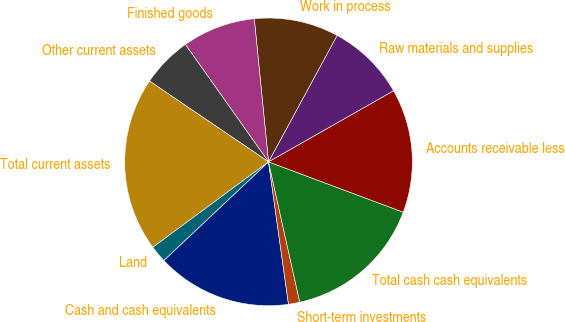<chart> <loc_0><loc_0><loc_500><loc_500><pie_chart><fcel>Cash and cash equivalents<fcel>Short-term investments<fcel>Total cash cash equivalents<fcel>Accounts receivable less<fcel>Raw materials and supplies<fcel>Work in process<fcel>Finished goods<fcel>Other current assets<fcel>Total current assets<fcel>Land<nl><fcel>15.19%<fcel>1.27%<fcel>15.82%<fcel>13.92%<fcel>8.86%<fcel>9.49%<fcel>8.23%<fcel>5.7%<fcel>19.62%<fcel>1.9%<nl></chart> 